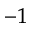Convert formula to latex. <formula><loc_0><loc_0><loc_500><loc_500>^ { - 1 }</formula> 